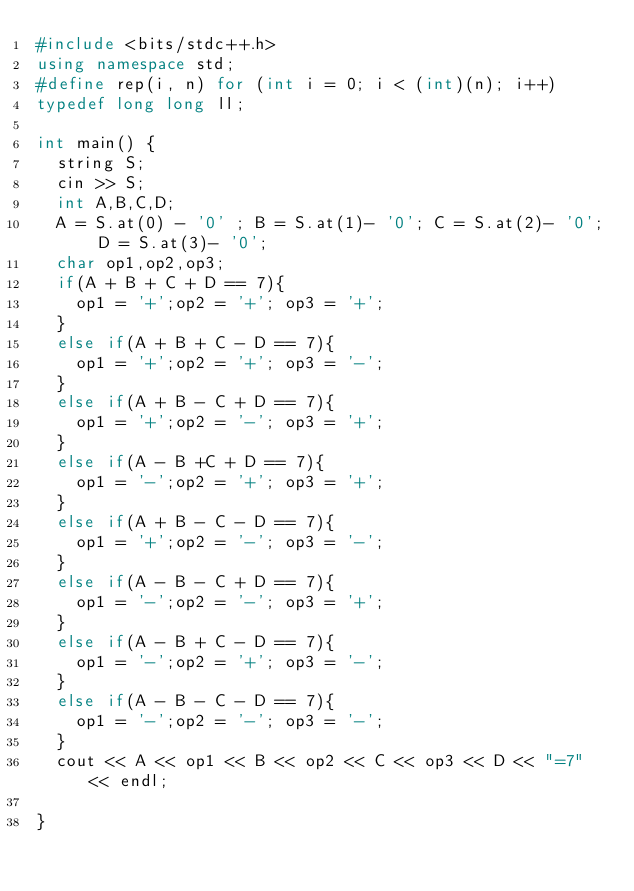Convert code to text. <code><loc_0><loc_0><loc_500><loc_500><_C++_>#include <bits/stdc++.h>
using namespace std;
#define rep(i, n) for (int i = 0; i < (int)(n); i++)
typedef long long ll;

int main() {
  string S;
  cin >> S;
  int A,B,C,D;
  A = S.at(0) - '0' ; B = S.at(1)- '0'; C = S.at(2)- '0'; D = S.at(3)- '0';
  char op1,op2,op3;
  if(A + B + C + D == 7){
    op1 = '+';op2 = '+'; op3 = '+';
  }
  else if(A + B + C - D == 7){
    op1 = '+';op2 = '+'; op3 = '-';
  }
  else if(A + B - C + D == 7){
    op1 = '+';op2 = '-'; op3 = '+';
  }
  else if(A - B +C + D == 7){
    op1 = '-';op2 = '+'; op3 = '+';
  }
  else if(A + B - C - D == 7){
    op1 = '+';op2 = '-'; op3 = '-';
  }
  else if(A - B - C + D == 7){
    op1 = '-';op2 = '-'; op3 = '+';
  }
  else if(A - B + C - D == 7){
    op1 = '-';op2 = '+'; op3 = '-';
  }
  else if(A - B - C - D == 7){
    op1 = '-';op2 = '-'; op3 = '-';
  }
  cout << A << op1 << B << op2 << C << op3 << D << "=7" << endl;
  
}

</code> 